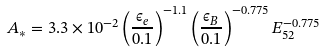Convert formula to latex. <formula><loc_0><loc_0><loc_500><loc_500>A _ { * } = 3 . 3 \times 1 0 ^ { - 2 } \left ( \frac { \epsilon _ { e } } { 0 . 1 } \right ) ^ { - 1 . 1 } \left ( \frac { \epsilon _ { B } } { 0 . 1 } \right ) ^ { - 0 . 7 7 5 } E _ { 5 2 } ^ { - 0 . 7 7 5 }</formula> 